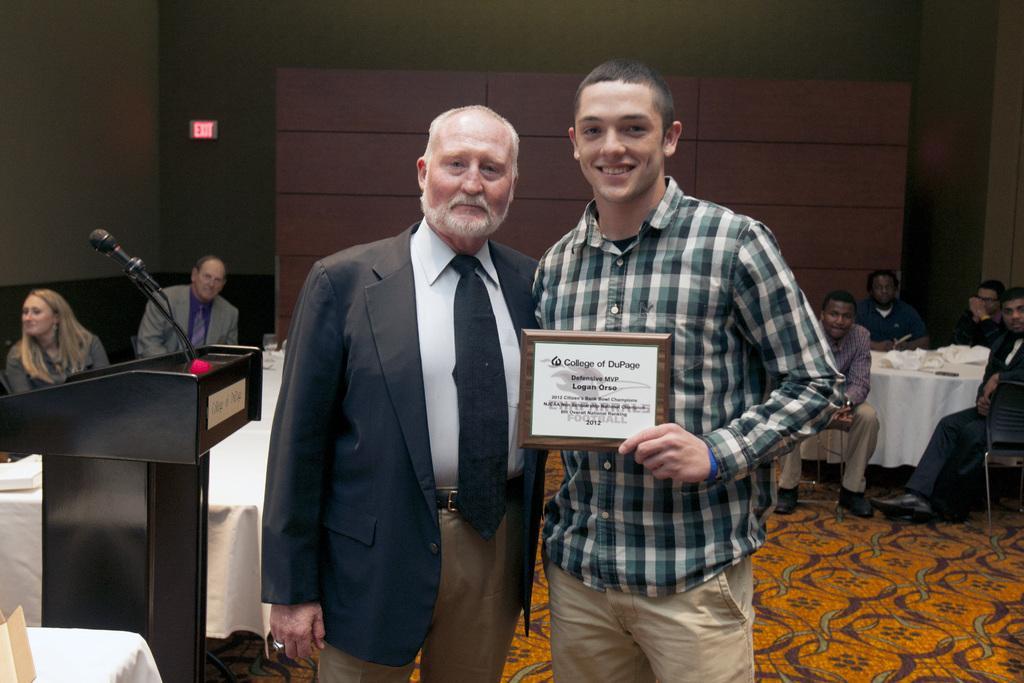Could you give a brief overview of what you see in this image? In this picture there are two men who are standing, there is a man in checks shirt is holding an award in his hand. There is a mic and a podium. There are few people who are sitting on the chair. There are few objects and a white cloth on the table. There is a man and a woman sitting in the corner. There is an orange brown carpet. 